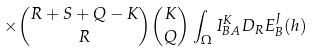Convert formula to latex. <formula><loc_0><loc_0><loc_500><loc_500>\times { { R + S + Q - K } \choose R } { K \choose Q } \int _ { \Omega } I ^ { K } _ { B A } D _ { R } E ^ { J } _ { B } ( h )</formula> 